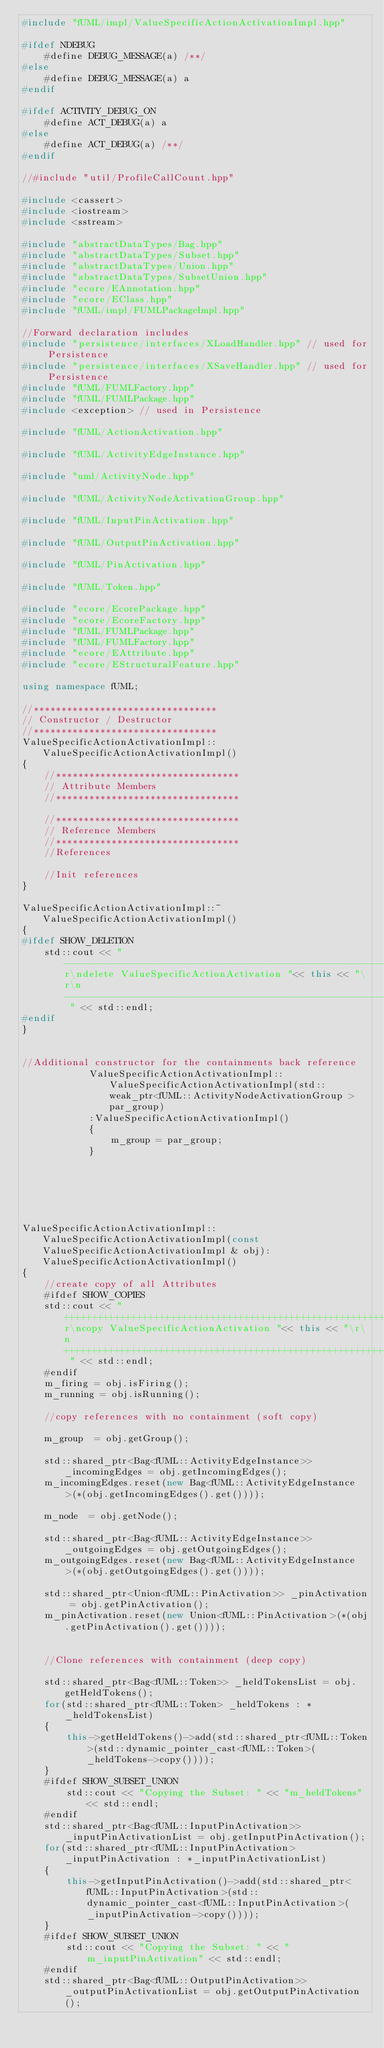<code> <loc_0><loc_0><loc_500><loc_500><_C++_>#include "fUML/impl/ValueSpecificActionActivationImpl.hpp"

#ifdef NDEBUG
	#define DEBUG_MESSAGE(a) /**/
#else
	#define DEBUG_MESSAGE(a) a
#endif

#ifdef ACTIVITY_DEBUG_ON
    #define ACT_DEBUG(a) a
#else
    #define ACT_DEBUG(a) /**/
#endif

//#include "util/ProfileCallCount.hpp"

#include <cassert>
#include <iostream>
#include <sstream>

#include "abstractDataTypes/Bag.hpp"
#include "abstractDataTypes/Subset.hpp"
#include "abstractDataTypes/Union.hpp"
#include "abstractDataTypes/SubsetUnion.hpp"
#include "ecore/EAnnotation.hpp"
#include "ecore/EClass.hpp"
#include "fUML/impl/FUMLPackageImpl.hpp"

//Forward declaration includes
#include "persistence/interfaces/XLoadHandler.hpp" // used for Persistence
#include "persistence/interfaces/XSaveHandler.hpp" // used for Persistence
#include "fUML/FUMLFactory.hpp"
#include "fUML/FUMLPackage.hpp"
#include <exception> // used in Persistence

#include "fUML/ActionActivation.hpp"

#include "fUML/ActivityEdgeInstance.hpp"

#include "uml/ActivityNode.hpp"

#include "fUML/ActivityNodeActivationGroup.hpp"

#include "fUML/InputPinActivation.hpp"

#include "fUML/OutputPinActivation.hpp"

#include "fUML/PinActivation.hpp"

#include "fUML/Token.hpp"

#include "ecore/EcorePackage.hpp"
#include "ecore/EcoreFactory.hpp"
#include "fUML/FUMLPackage.hpp"
#include "fUML/FUMLFactory.hpp"
#include "ecore/EAttribute.hpp"
#include "ecore/EStructuralFeature.hpp"

using namespace fUML;

//*********************************
// Constructor / Destructor
//*********************************
ValueSpecificActionActivationImpl::ValueSpecificActionActivationImpl()
{
	//*********************************
	// Attribute Members
	//*********************************

	//*********************************
	// Reference Members
	//*********************************
	//References

	//Init references
}

ValueSpecificActionActivationImpl::~ValueSpecificActionActivationImpl()
{
#ifdef SHOW_DELETION
	std::cout << "-------------------------------------------------------------------------------------------------\r\ndelete ValueSpecificActionActivation "<< this << "\r\n------------------------------------------------------------------------ " << std::endl;
#endif
}


//Additional constructor for the containments back reference
			ValueSpecificActionActivationImpl::ValueSpecificActionActivationImpl(std::weak_ptr<fUML::ActivityNodeActivationGroup > par_group)
			:ValueSpecificActionActivationImpl()
			{
			    m_group = par_group;
			}






ValueSpecificActionActivationImpl::ValueSpecificActionActivationImpl(const ValueSpecificActionActivationImpl & obj):ValueSpecificActionActivationImpl()
{
	//create copy of all Attributes
	#ifdef SHOW_COPIES
	std::cout << "+++++++++++++++++++++++++++++++++++++++++++++++++++++++++++++++++++++++++\r\ncopy ValueSpecificActionActivation "<< this << "\r\n+++++++++++++++++++++++++++++++++++++++++++++++++++++++++++++++++++++++++ " << std::endl;
	#endif
	m_firing = obj.isFiring();
	m_running = obj.isRunning();

	//copy references with no containment (soft copy)
	
	m_group  = obj.getGroup();

	std::shared_ptr<Bag<fUML::ActivityEdgeInstance>> _incomingEdges = obj.getIncomingEdges();
	m_incomingEdges.reset(new Bag<fUML::ActivityEdgeInstance>(*(obj.getIncomingEdges().get())));

	m_node  = obj.getNode();

	std::shared_ptr<Bag<fUML::ActivityEdgeInstance>> _outgoingEdges = obj.getOutgoingEdges();
	m_outgoingEdges.reset(new Bag<fUML::ActivityEdgeInstance>(*(obj.getOutgoingEdges().get())));

	std::shared_ptr<Union<fUML::PinActivation>> _pinActivation = obj.getPinActivation();
	m_pinActivation.reset(new Union<fUML::PinActivation>(*(obj.getPinActivation().get())));


	//Clone references with containment (deep copy)

	std::shared_ptr<Bag<fUML::Token>> _heldTokensList = obj.getHeldTokens();
	for(std::shared_ptr<fUML::Token> _heldTokens : *_heldTokensList)
	{
		this->getHeldTokens()->add(std::shared_ptr<fUML::Token>(std::dynamic_pointer_cast<fUML::Token>(_heldTokens->copy())));
	}
	#ifdef SHOW_SUBSET_UNION
		std::cout << "Copying the Subset: " << "m_heldTokens" << std::endl;
	#endif
	std::shared_ptr<Bag<fUML::InputPinActivation>> _inputPinActivationList = obj.getInputPinActivation();
	for(std::shared_ptr<fUML::InputPinActivation> _inputPinActivation : *_inputPinActivationList)
	{
		this->getInputPinActivation()->add(std::shared_ptr<fUML::InputPinActivation>(std::dynamic_pointer_cast<fUML::InputPinActivation>(_inputPinActivation->copy())));
	}
	#ifdef SHOW_SUBSET_UNION
		std::cout << "Copying the Subset: " << "m_inputPinActivation" << std::endl;
	#endif
	std::shared_ptr<Bag<fUML::OutputPinActivation>> _outputPinActivationList = obj.getOutputPinActivation();</code> 